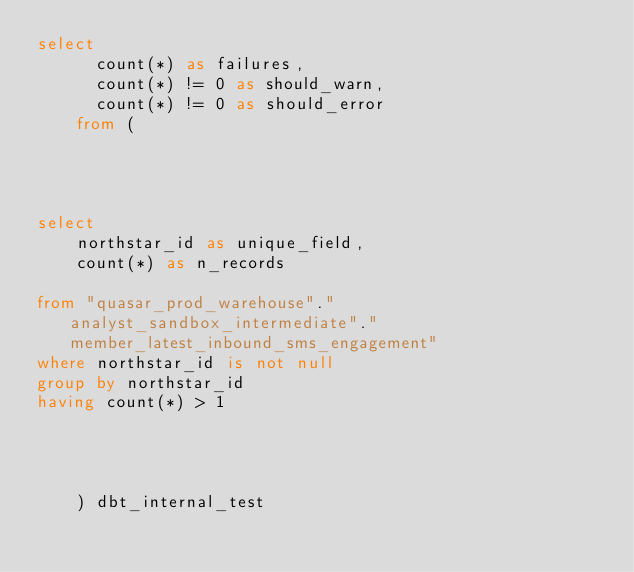<code> <loc_0><loc_0><loc_500><loc_500><_SQL_>select
      count(*) as failures,
      count(*) != 0 as should_warn,
      count(*) != 0 as should_error
    from (
      
    
    

select
    northstar_id as unique_field,
    count(*) as n_records

from "quasar_prod_warehouse"."analyst_sandbox_intermediate"."member_latest_inbound_sms_engagement"
where northstar_id is not null
group by northstar_id
having count(*) > 1



      
    ) dbt_internal_test</code> 